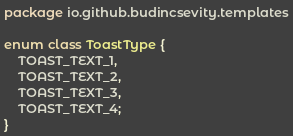<code> <loc_0><loc_0><loc_500><loc_500><_Kotlin_>package io.github.budincsevity.templates

enum class ToastType {
    TOAST_TEXT_1,
    TOAST_TEXT_2,
    TOAST_TEXT_3,
    TOAST_TEXT_4;
}
</code> 